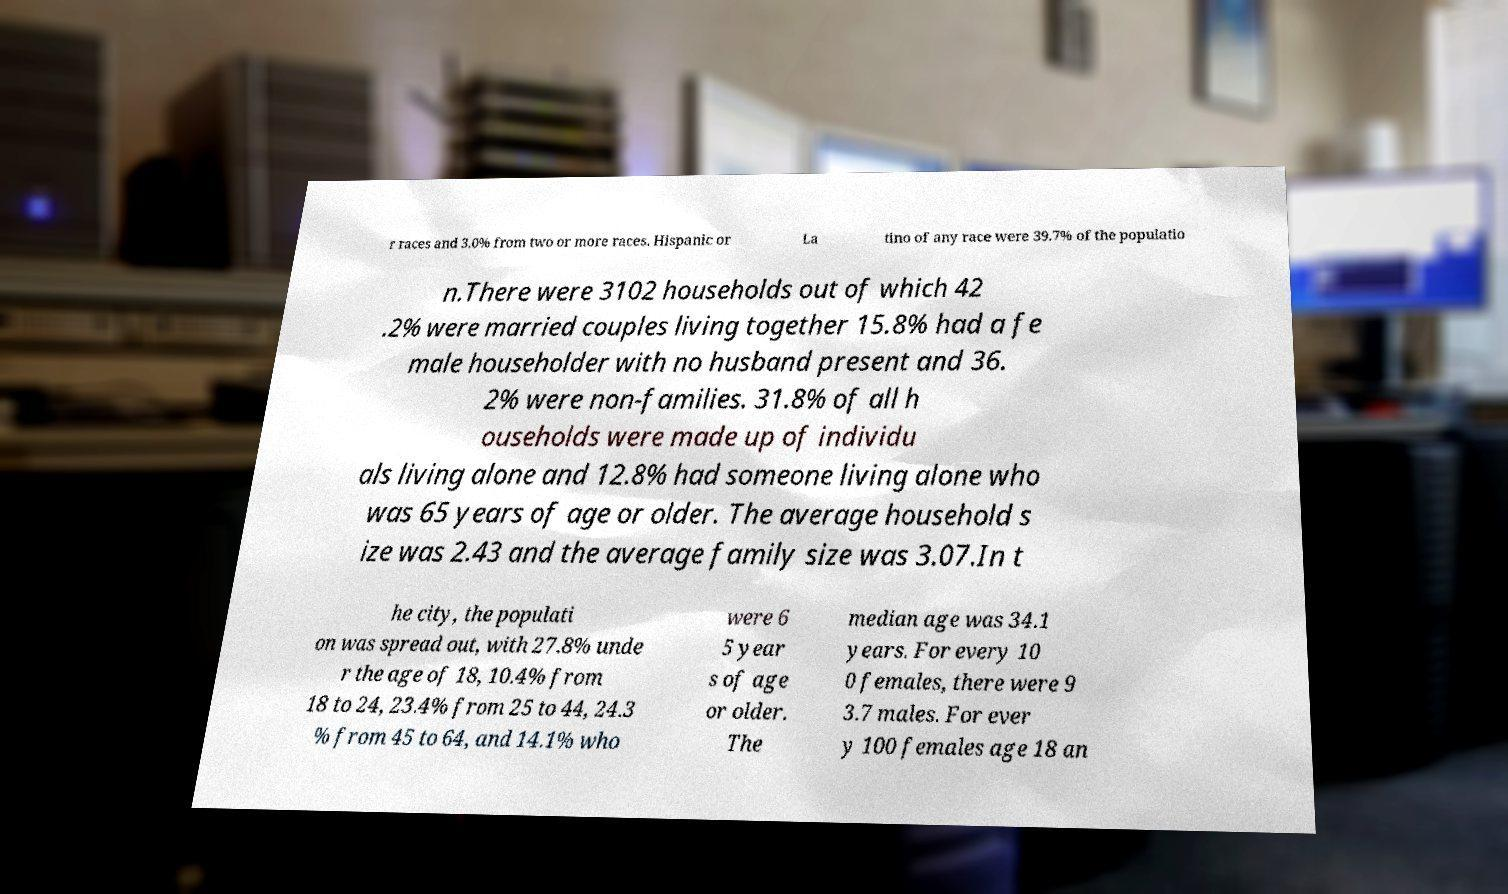I need the written content from this picture converted into text. Can you do that? r races and 3.0% from two or more races. Hispanic or La tino of any race were 39.7% of the populatio n.There were 3102 households out of which 42 .2% were married couples living together 15.8% had a fe male householder with no husband present and 36. 2% were non-families. 31.8% of all h ouseholds were made up of individu als living alone and 12.8% had someone living alone who was 65 years of age or older. The average household s ize was 2.43 and the average family size was 3.07.In t he city, the populati on was spread out, with 27.8% unde r the age of 18, 10.4% from 18 to 24, 23.4% from 25 to 44, 24.3 % from 45 to 64, and 14.1% who were 6 5 year s of age or older. The median age was 34.1 years. For every 10 0 females, there were 9 3.7 males. For ever y 100 females age 18 an 